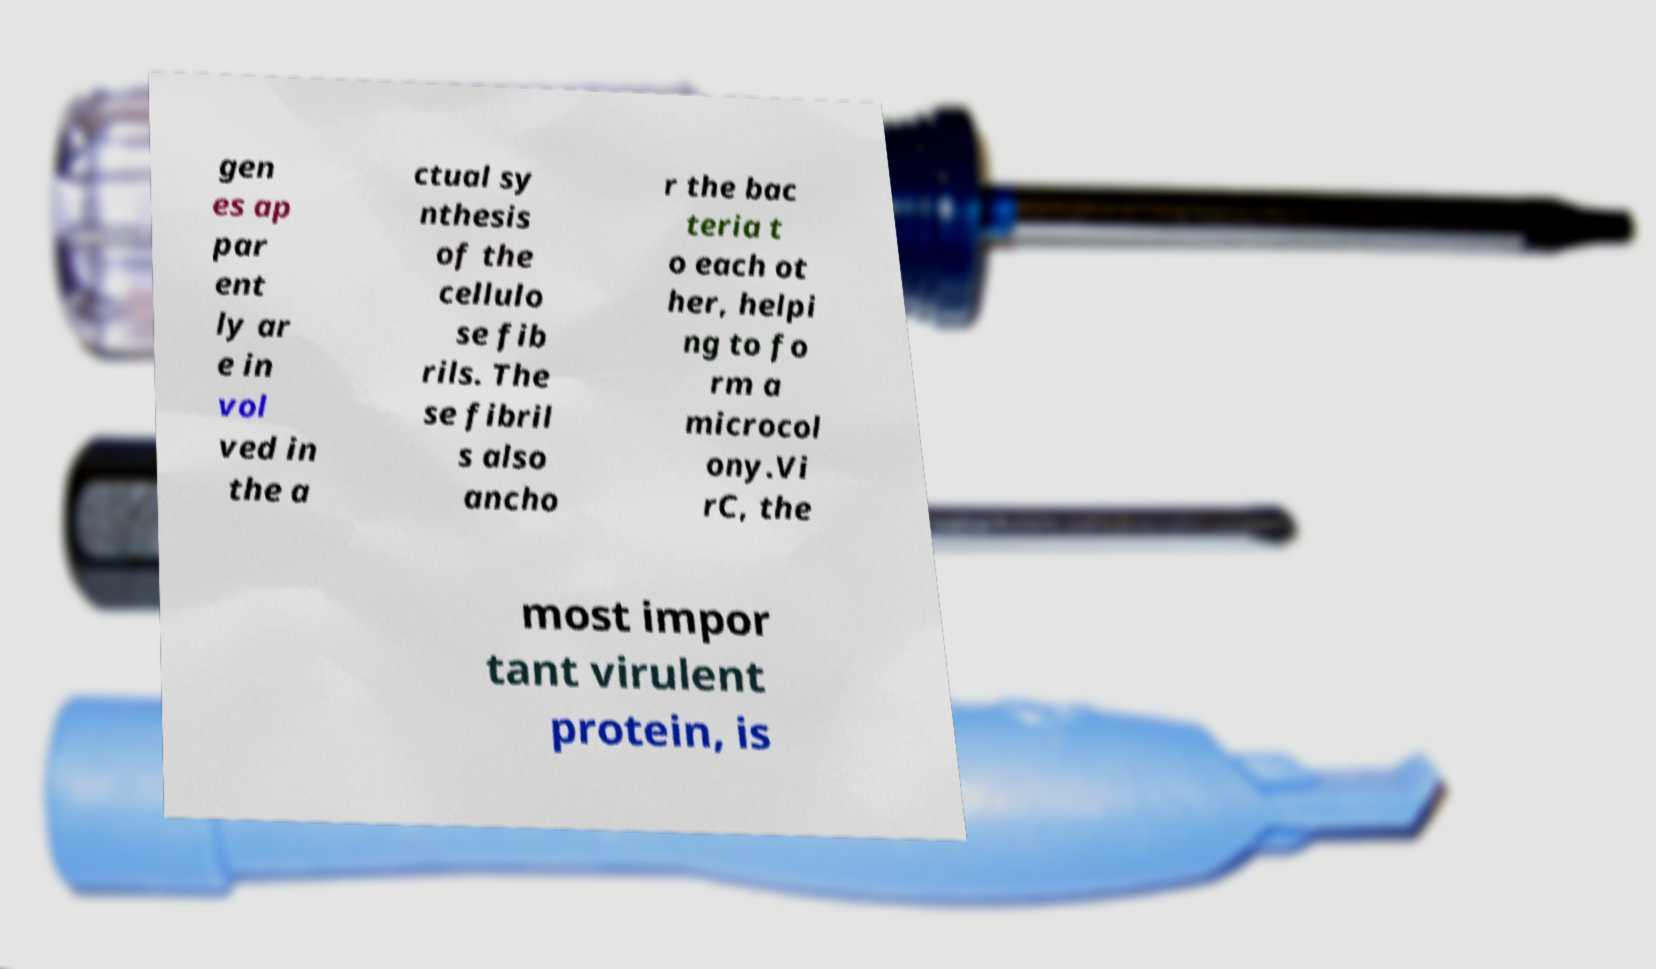Could you assist in decoding the text presented in this image and type it out clearly? gen es ap par ent ly ar e in vol ved in the a ctual sy nthesis of the cellulo se fib rils. The se fibril s also ancho r the bac teria t o each ot her, helpi ng to fo rm a microcol ony.Vi rC, the most impor tant virulent protein, is 